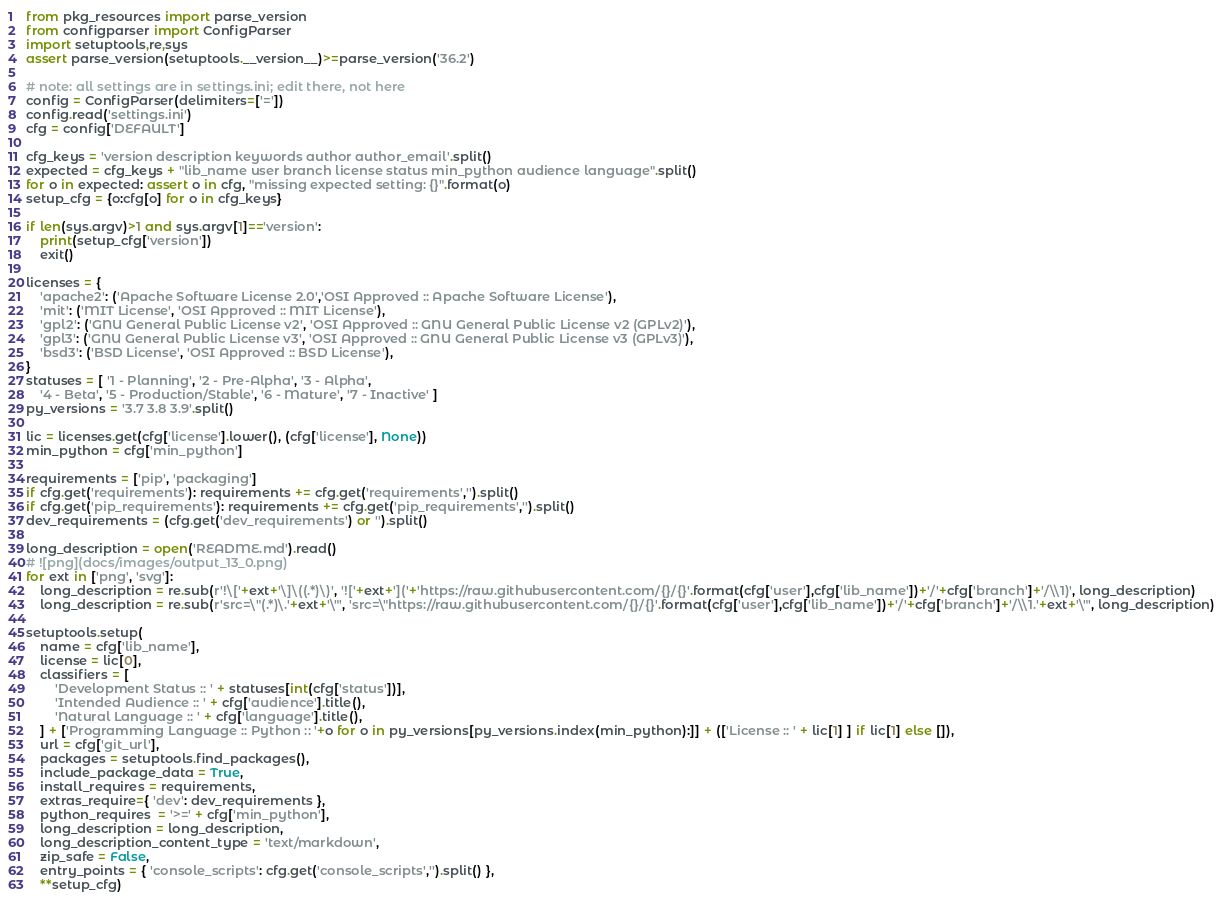Convert code to text. <code><loc_0><loc_0><loc_500><loc_500><_Python_>from pkg_resources import parse_version
from configparser import ConfigParser
import setuptools,re,sys
assert parse_version(setuptools.__version__)>=parse_version('36.2')

# note: all settings are in settings.ini; edit there, not here
config = ConfigParser(delimiters=['='])
config.read('settings.ini')
cfg = config['DEFAULT']

cfg_keys = 'version description keywords author author_email'.split()
expected = cfg_keys + "lib_name user branch license status min_python audience language".split()
for o in expected: assert o in cfg, "missing expected setting: {}".format(o)
setup_cfg = {o:cfg[o] for o in cfg_keys}

if len(sys.argv)>1 and sys.argv[1]=='version':
    print(setup_cfg['version'])
    exit()

licenses = {
    'apache2': ('Apache Software License 2.0','OSI Approved :: Apache Software License'),
    'mit': ('MIT License', 'OSI Approved :: MIT License'),
    'gpl2': ('GNU General Public License v2', 'OSI Approved :: GNU General Public License v2 (GPLv2)'),
    'gpl3': ('GNU General Public License v3', 'OSI Approved :: GNU General Public License v3 (GPLv3)'),
    'bsd3': ('BSD License', 'OSI Approved :: BSD License'),
}
statuses = [ '1 - Planning', '2 - Pre-Alpha', '3 - Alpha',
    '4 - Beta', '5 - Production/Stable', '6 - Mature', '7 - Inactive' ]
py_versions = '3.7 3.8 3.9'.split()

lic = licenses.get(cfg['license'].lower(), (cfg['license'], None))
min_python = cfg['min_python']

requirements = ['pip', 'packaging']
if cfg.get('requirements'): requirements += cfg.get('requirements','').split()
if cfg.get('pip_requirements'): requirements += cfg.get('pip_requirements','').split()
dev_requirements = (cfg.get('dev_requirements') or '').split()

long_description = open('README.md').read()
# ![png](docs/images/output_13_0.png)
for ext in ['png', 'svg']:
    long_description = re.sub(r'!\['+ext+'\]\((.*)\)', '!['+ext+']('+'https://raw.githubusercontent.com/{}/{}'.format(cfg['user'],cfg['lib_name'])+'/'+cfg['branch']+'/\\1)', long_description)
    long_description = re.sub(r'src=\"(.*)\.'+ext+'\"', 'src=\"https://raw.githubusercontent.com/{}/{}'.format(cfg['user'],cfg['lib_name'])+'/'+cfg['branch']+'/\\1.'+ext+'\"', long_description)

setuptools.setup(
    name = cfg['lib_name'],
    license = lic[0],
    classifiers = [
        'Development Status :: ' + statuses[int(cfg['status'])],
        'Intended Audience :: ' + cfg['audience'].title(),
        'Natural Language :: ' + cfg['language'].title(),
    ] + ['Programming Language :: Python :: '+o for o in py_versions[py_versions.index(min_python):]] + (['License :: ' + lic[1] ] if lic[1] else []),
    url = cfg['git_url'],
    packages = setuptools.find_packages(),
    include_package_data = True,
    install_requires = requirements,
    extras_require={ 'dev': dev_requirements },
    python_requires  = '>=' + cfg['min_python'],
    long_description = long_description,
    long_description_content_type = 'text/markdown',
    zip_safe = False,
    entry_points = { 'console_scripts': cfg.get('console_scripts','').split() },
    **setup_cfg)

</code> 